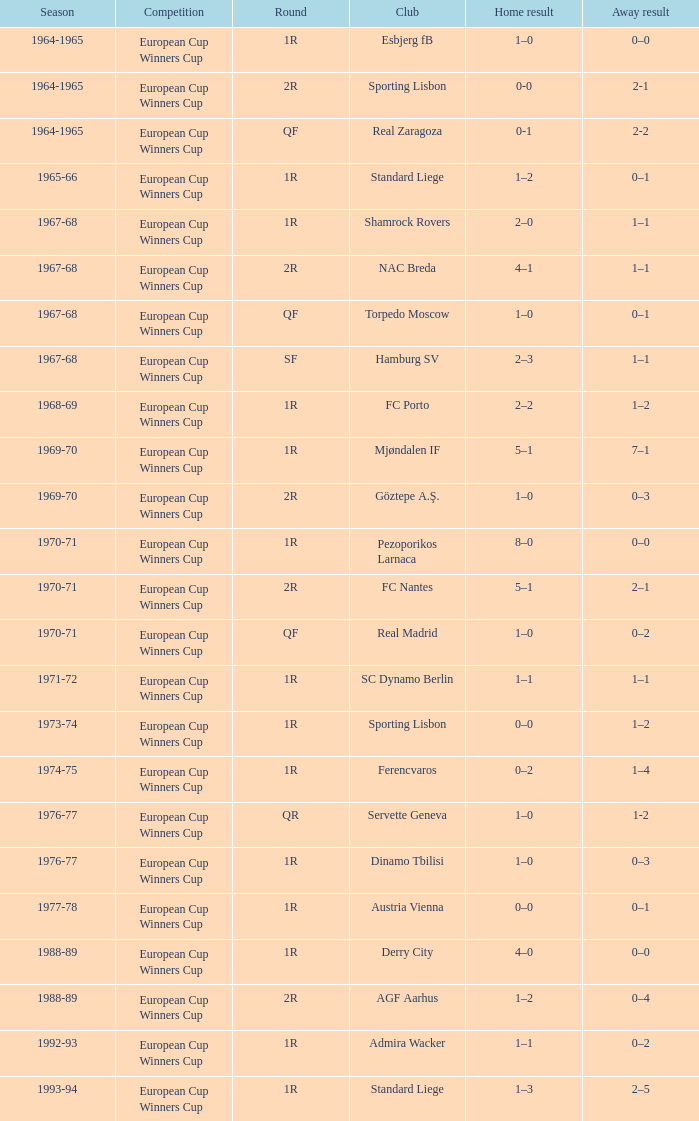Which competition featured a 0-3 away outcome in the 1969-70 season? European Cup Winners Cup. 